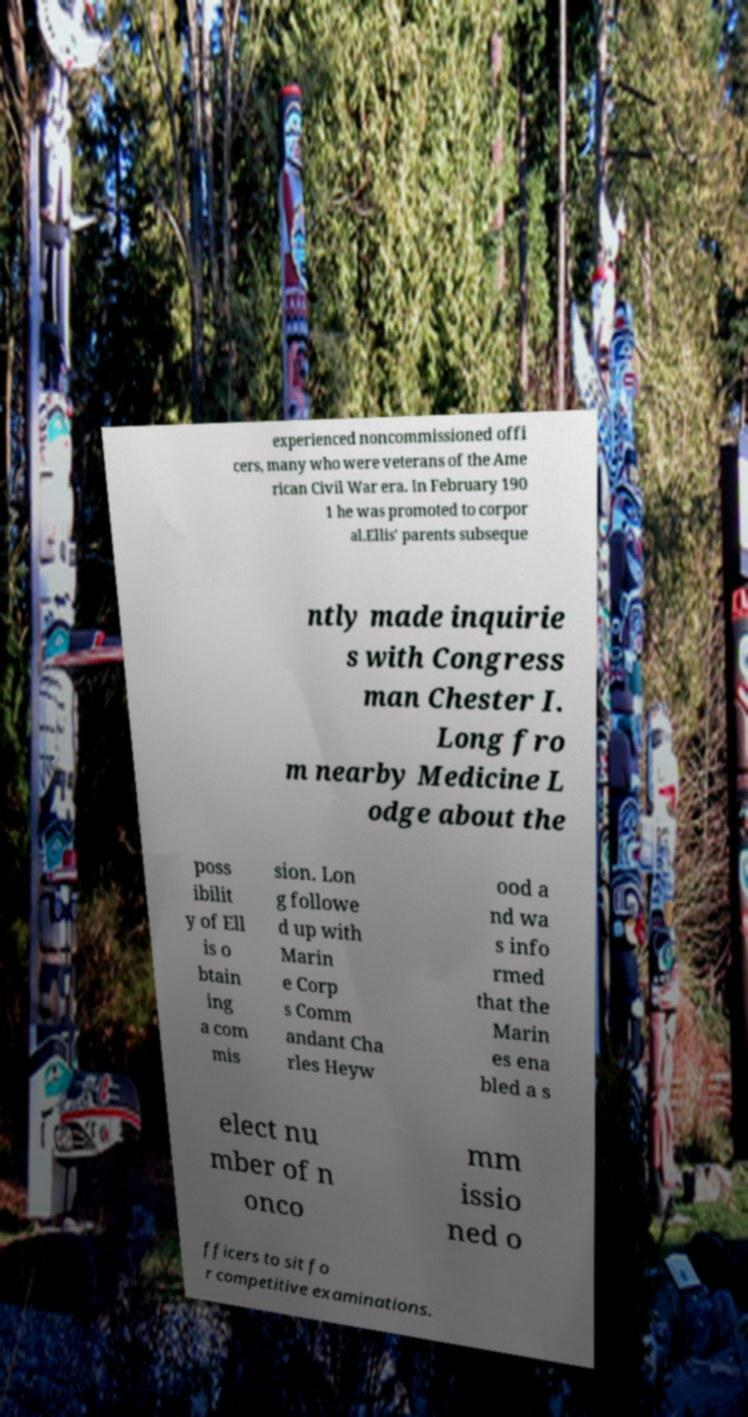What messages or text are displayed in this image? I need them in a readable, typed format. experienced noncommissioned offi cers, many who were veterans of the Ame rican Civil War era. In February 190 1 he was promoted to corpor al.Ellis' parents subseque ntly made inquirie s with Congress man Chester I. Long fro m nearby Medicine L odge about the poss ibilit y of Ell is o btain ing a com mis sion. Lon g followe d up with Marin e Corp s Comm andant Cha rles Heyw ood a nd wa s info rmed that the Marin es ena bled a s elect nu mber of n onco mm issio ned o fficers to sit fo r competitive examinations. 